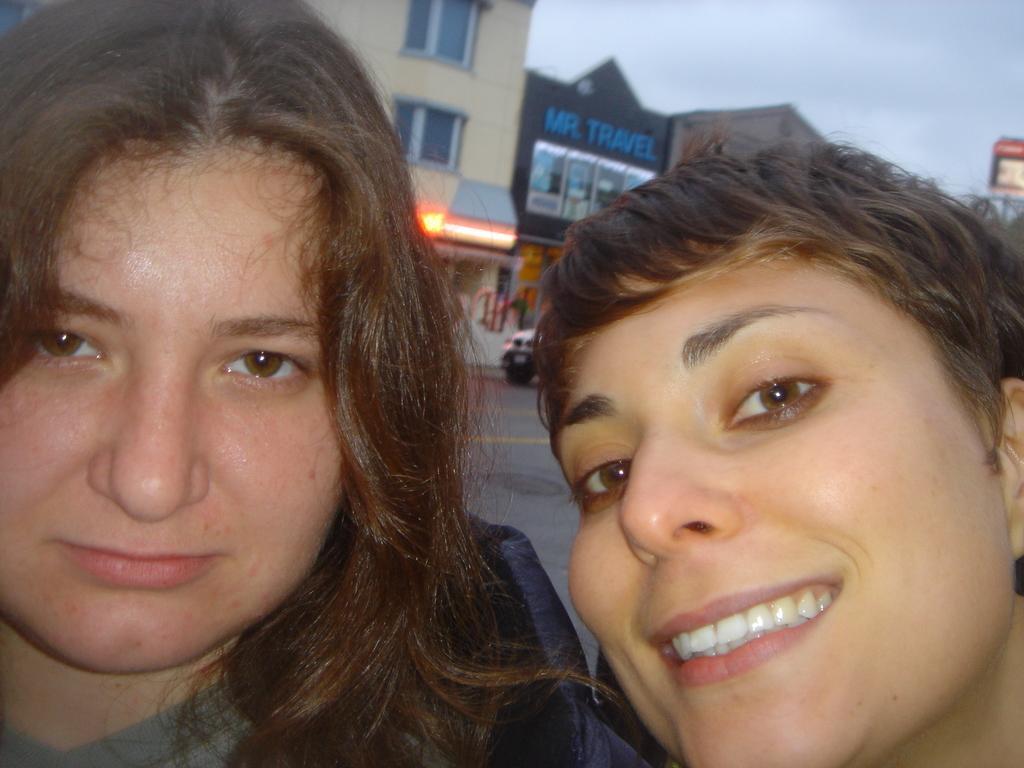How would you summarize this image in a sentence or two? There are two women. One of them is smiling. In the background, there is a road. On which, there is a vehicle, there are hoardings, buildings and clouds in the sky. 